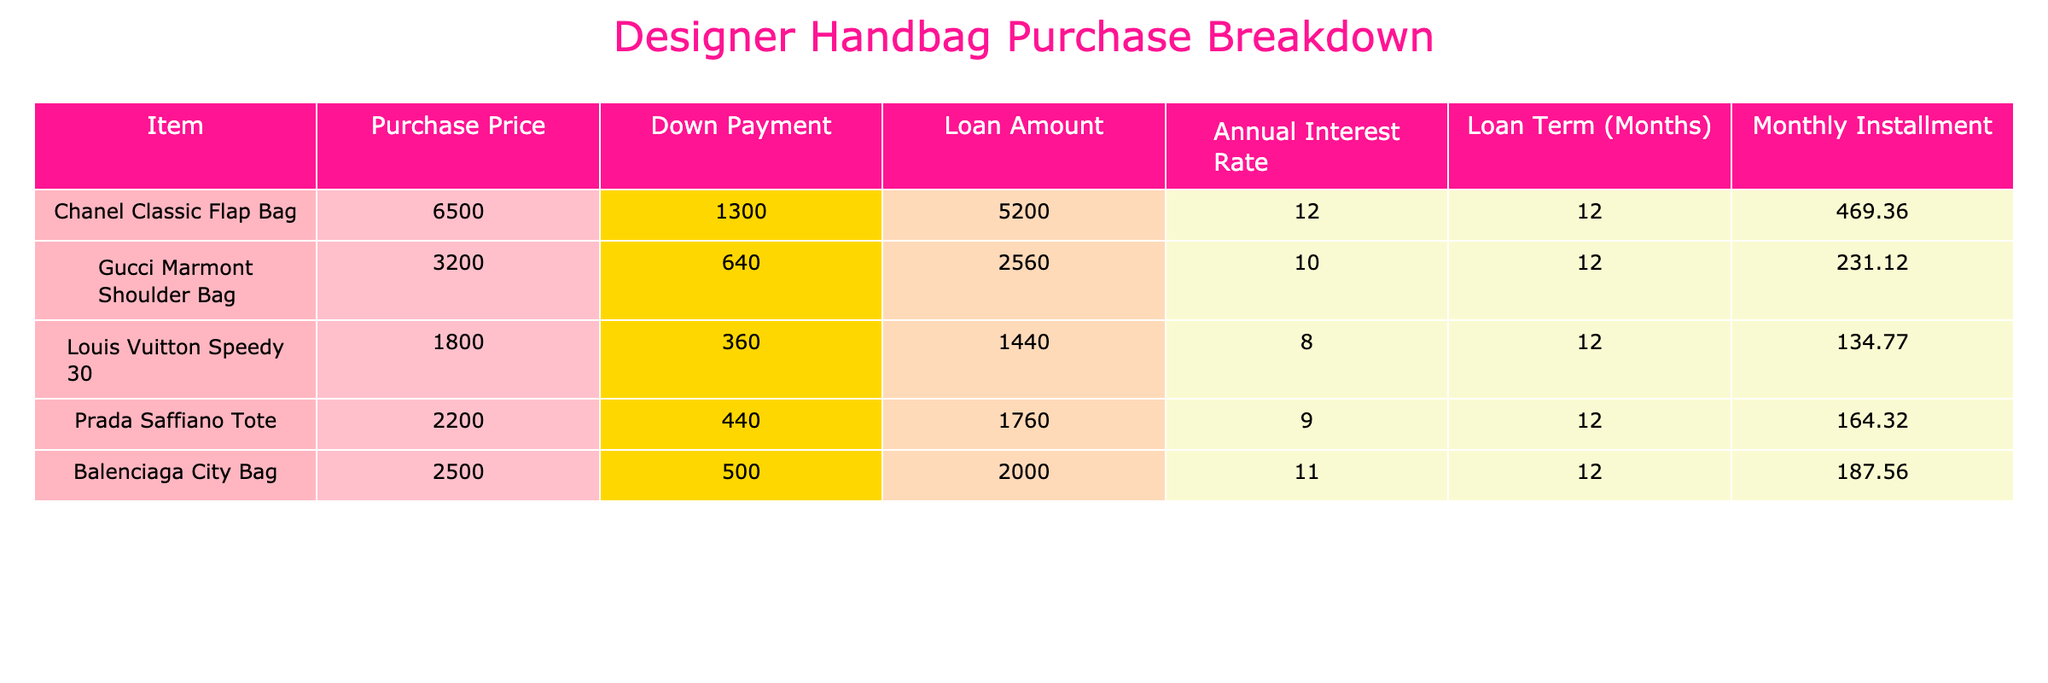What is the monthly installment for the Chanel Classic Flap Bag? The table lists the monthly installment for the Chanel Classic Flap Bag under the 'Monthly Installment' column, which shows the value as 469.36.
Answer: 469.36 How much is the down payment for the Gucci Marmont Shoulder Bag? The down payment for the Gucci Marmont Shoulder Bag is directly listed in the 'Down Payment' column, which indicates the amount as 640.
Answer: 640 Which handbag has the highest purchase price and what is that amount? The table reveals the purchase prices for each handbag. By comparing all values, the Chanel Classic Flap Bag has the highest price at 6500.
Answer: 6500 What is the total loan amount for all bags listed in the table? To find the total loan amount, sum the 'Loan Amount' column values: 5200 + 2560 + 1440 + 1760 + 2000 = 10960.
Answer: 10960 Is the annual interest rate for the Louis Vuitton Speedy 30 higher than 10 percent? The annual interest rate for the Louis Vuitton Speedy 30 is listed as 8 percent, which is lower than 10 percent, so the answer is no.
Answer: No What is the average monthly installment for all the handbags? To find the average, sum the monthly installments (469.36 + 231.12 + 134.77 + 164.32 + 187.56 = 1187.13) and divide by the number of bags (5). Thus, 1187.13 / 5 = 237.426, approximately 237.43.
Answer: 237.43 Does the Prada Saffiano Tote have a higher loan amount than the Louis Vuitton Speedy 30? The loan amount for the Prada Saffiano Tote is 1760, while for the Louis Vuitton Speedy 30 it is 1440. Since 1760 is greater than 1440, the answer is yes.
Answer: Yes What is the difference between the monthly installments of the Chanel Classic Flap Bag and the Balenciaga City Bag? The monthly installment for the Chanel Classic Flap Bag is 469.36 and for the Balenciaga City Bag, it is 187.56. The difference is 469.36 - 187.56 = 281.80.
Answer: 281.80 Which bag has the longest loan term, and what is that duration? By reviewing the 'Loan Term (Months)' column, the Chanel Classic Flap Bag has a loan term of 12 months, which is the longest compared to other bags in the list.
Answer: Chanel Classic Flap Bag, 12 months 